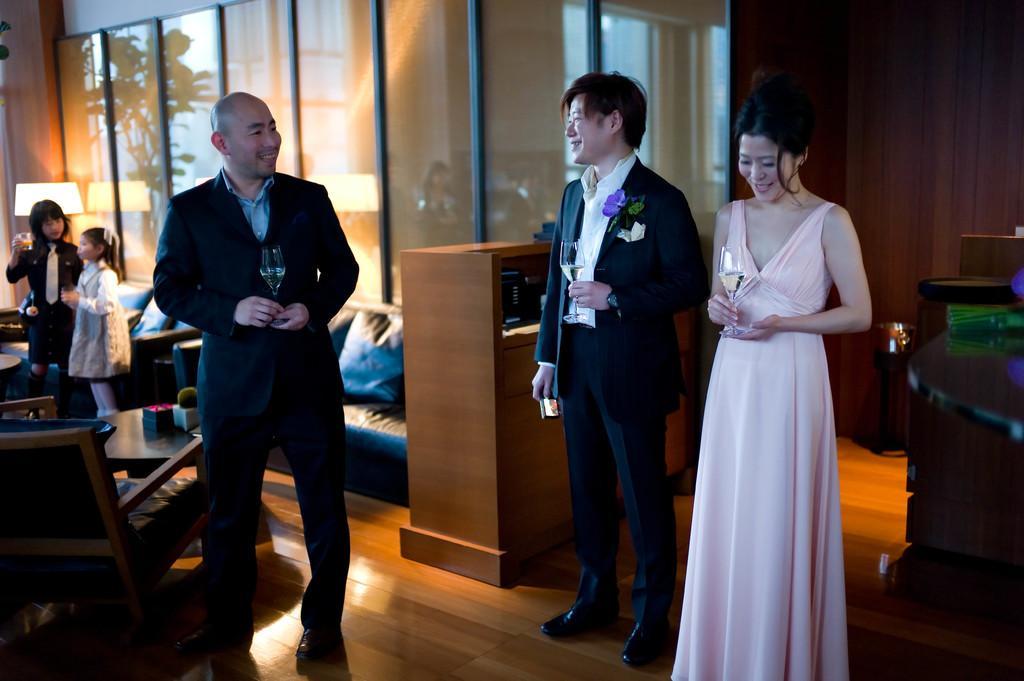How would you summarize this image in a sentence or two? This is an inside view. On the right side, I can see a woman and a man standing by holding glasses in their hands and smiling. On the the left side there is another man standing and smiling by looking at these people. Beside this man there are some chairs and tables. In the background, I can see two girls are standing. At the back of this man I can see a couch. In the background there is a wall. 